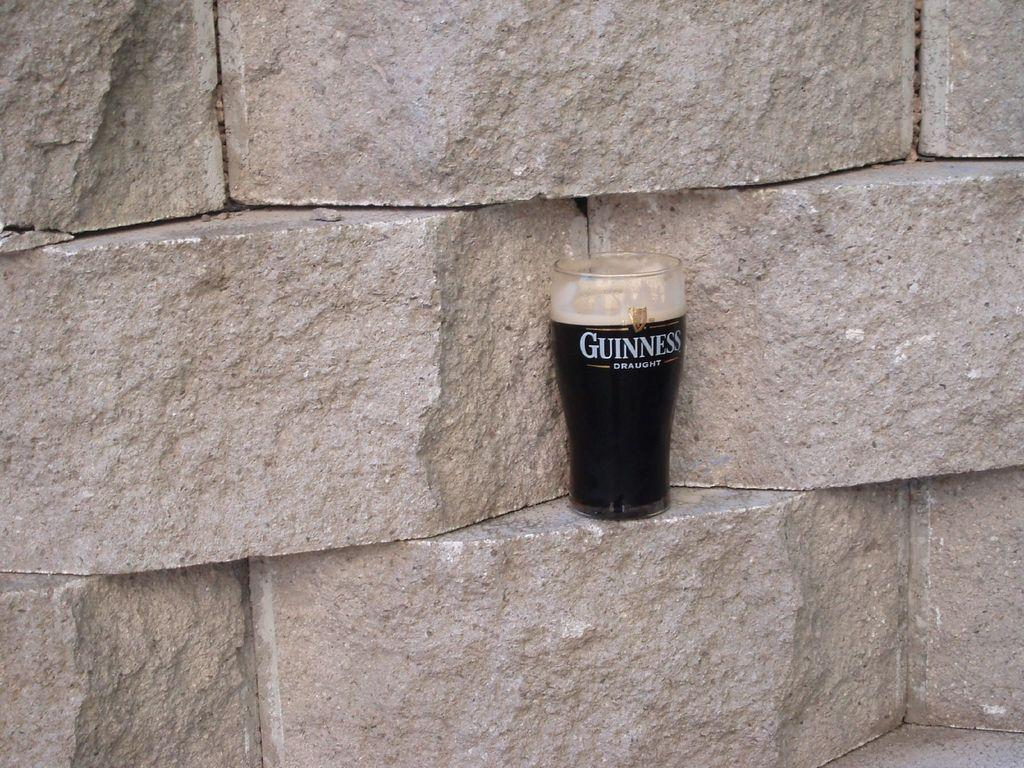<image>
Give a short and clear explanation of the subsequent image. A glass of Guinness is sitting on a stone wall. 